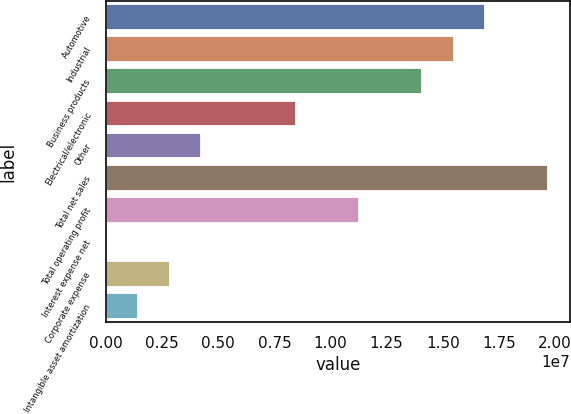Convert chart to OTSL. <chart><loc_0><loc_0><loc_500><loc_500><bar_chart><fcel>Automotive<fcel>Industrial<fcel>Business products<fcel>Electrical/electronic<fcel>Other<fcel>Total net sales<fcel>Total operating profit<fcel>Interest expense net<fcel>Corporate expense<fcel>Intangible asset amortization<nl><fcel>1.68885e+07<fcel>1.54832e+07<fcel>1.40778e+07<fcel>8.45644e+06<fcel>4.24038e+06<fcel>1.96992e+07<fcel>1.12671e+07<fcel>24330<fcel>2.83503e+06<fcel>1.42968e+06<nl></chart> 